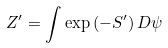<formula> <loc_0><loc_0><loc_500><loc_500>Z ^ { \prime } = \int \exp \left ( - S ^ { \prime } \right ) D \psi</formula> 